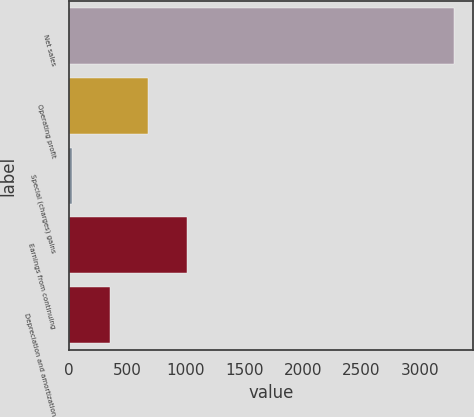<chart> <loc_0><loc_0><loc_500><loc_500><bar_chart><fcel>Net sales<fcel>Operating profit<fcel>Special (charges) gains<fcel>Earnings from continuing<fcel>Depreciation and amortization<nl><fcel>3292<fcel>677.6<fcel>24<fcel>1004.4<fcel>350.8<nl></chart> 